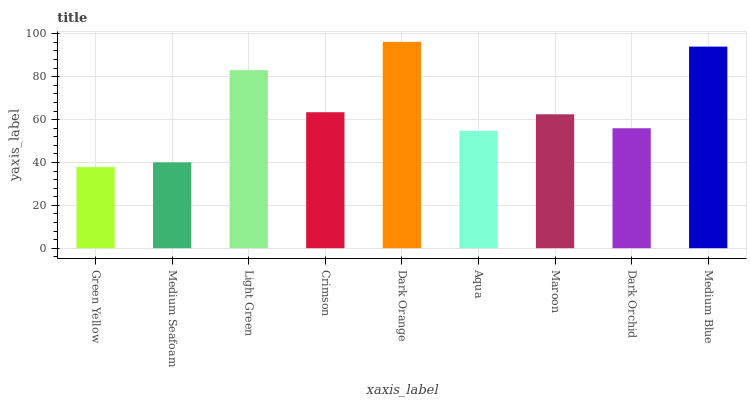Is Green Yellow the minimum?
Answer yes or no. Yes. Is Dark Orange the maximum?
Answer yes or no. Yes. Is Medium Seafoam the minimum?
Answer yes or no. No. Is Medium Seafoam the maximum?
Answer yes or no. No. Is Medium Seafoam greater than Green Yellow?
Answer yes or no. Yes. Is Green Yellow less than Medium Seafoam?
Answer yes or no. Yes. Is Green Yellow greater than Medium Seafoam?
Answer yes or no. No. Is Medium Seafoam less than Green Yellow?
Answer yes or no. No. Is Maroon the high median?
Answer yes or no. Yes. Is Maroon the low median?
Answer yes or no. Yes. Is Green Yellow the high median?
Answer yes or no. No. Is Crimson the low median?
Answer yes or no. No. 